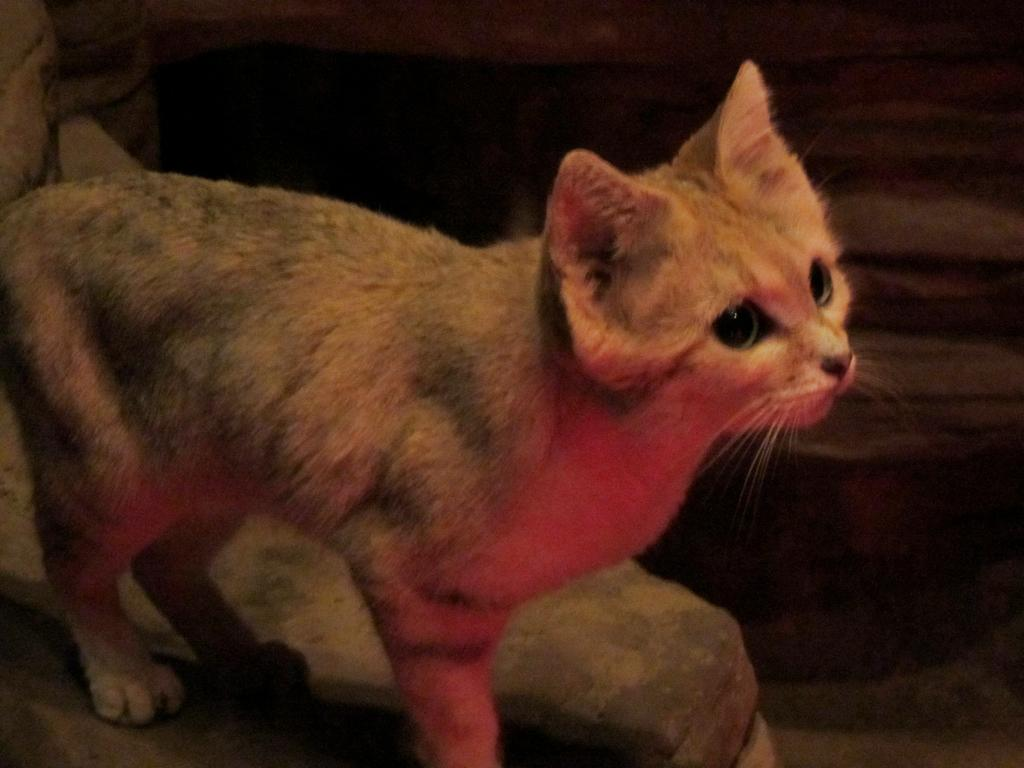What type of animal is in the image? There is a cat in the image. What can be observed about the background of the image? The background of the image is dark. What color is the loaf of bread in the image? There is no loaf of bread present in the image. 